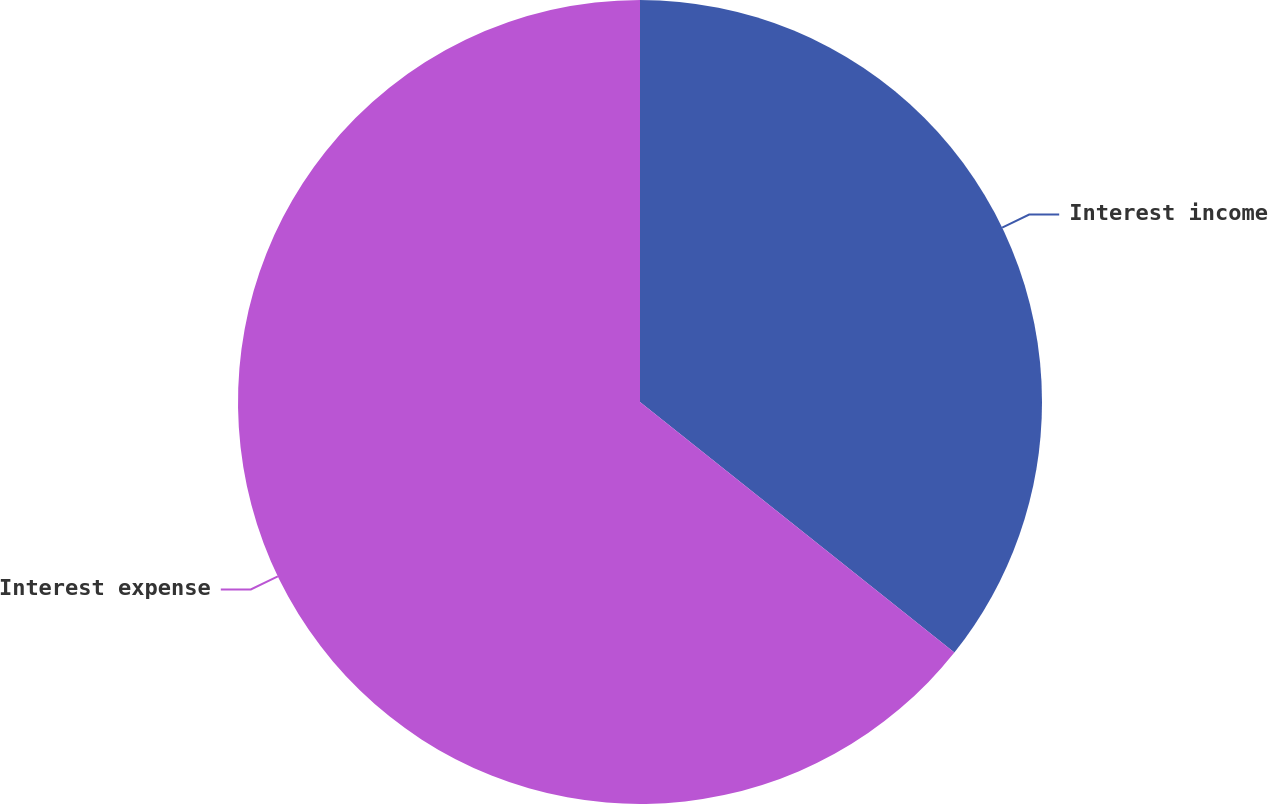Convert chart to OTSL. <chart><loc_0><loc_0><loc_500><loc_500><pie_chart><fcel>Interest income<fcel>Interest expense<nl><fcel>35.71%<fcel>64.29%<nl></chart> 